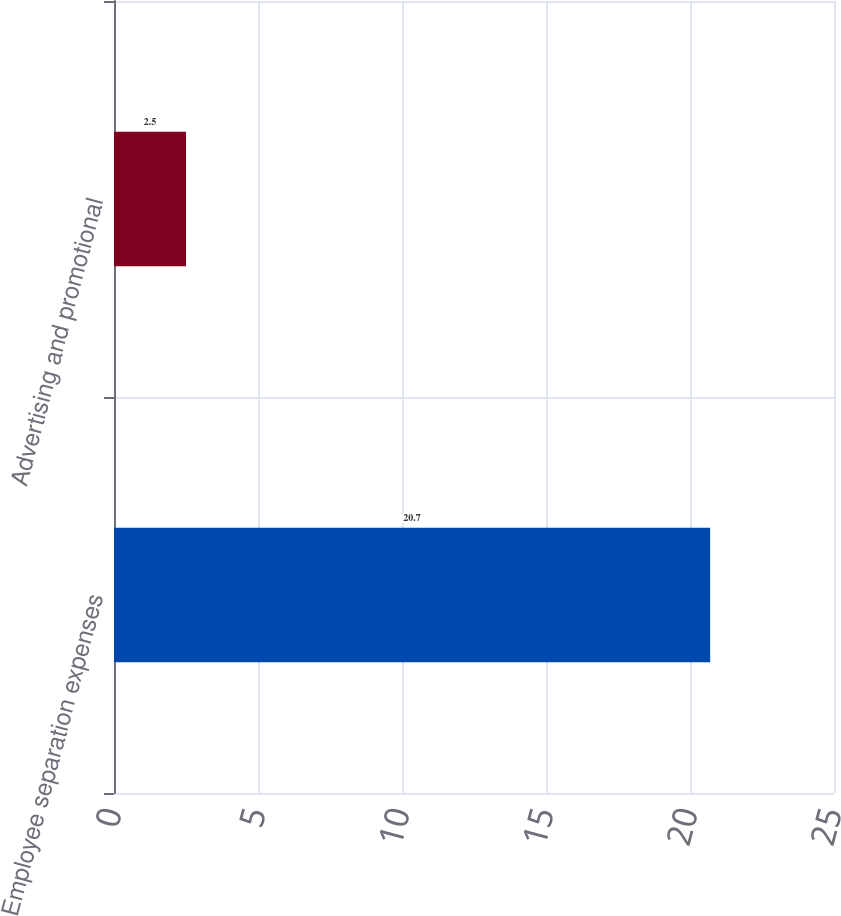Convert chart to OTSL. <chart><loc_0><loc_0><loc_500><loc_500><bar_chart><fcel>Employee separation expenses<fcel>Advertising and promotional<nl><fcel>20.7<fcel>2.5<nl></chart> 